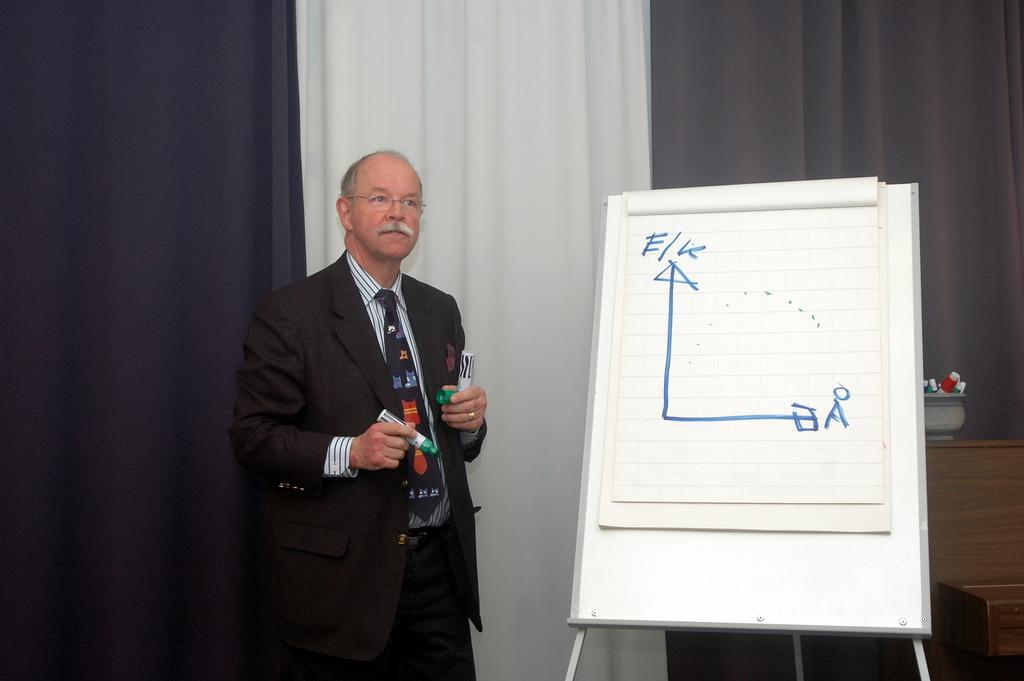What is the man doing in the image? The man is standing at the left side of the image and holding a marker. What object is present at the right side of the image? There is a white color board at the right side of the image. What can be seen in the background of the image? There are curtains in the background of the image. What type of dust can be seen on the color board in the image? There is no dust visible on the color board in the image. What sound can be heard coming from the sky in the image? There is no sound mentioned in the image, and the sky is not a focus of the image. 